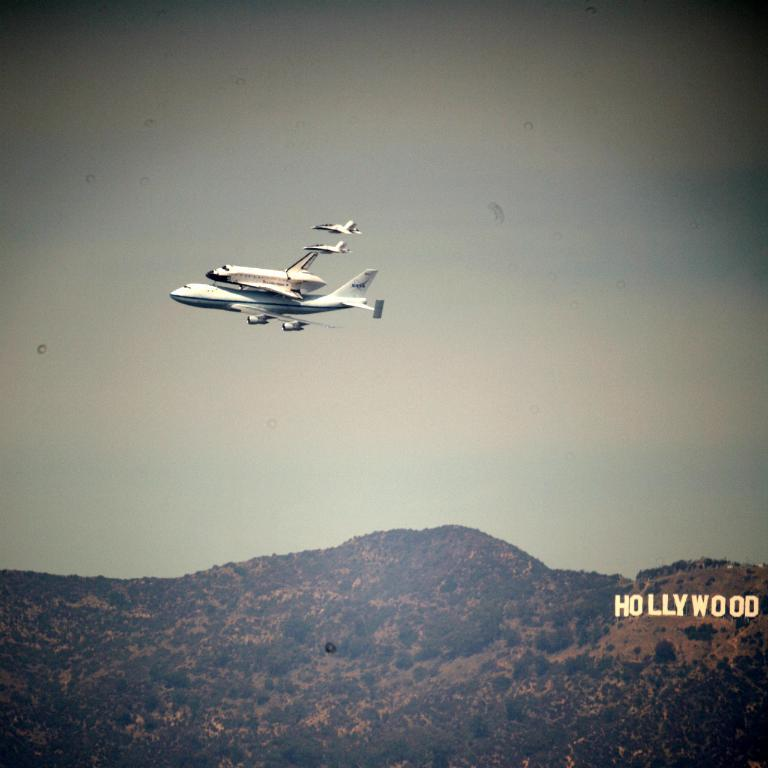Provide a one-sentence caption for the provided image. Planes flying in the air above the Hollywood sign. 